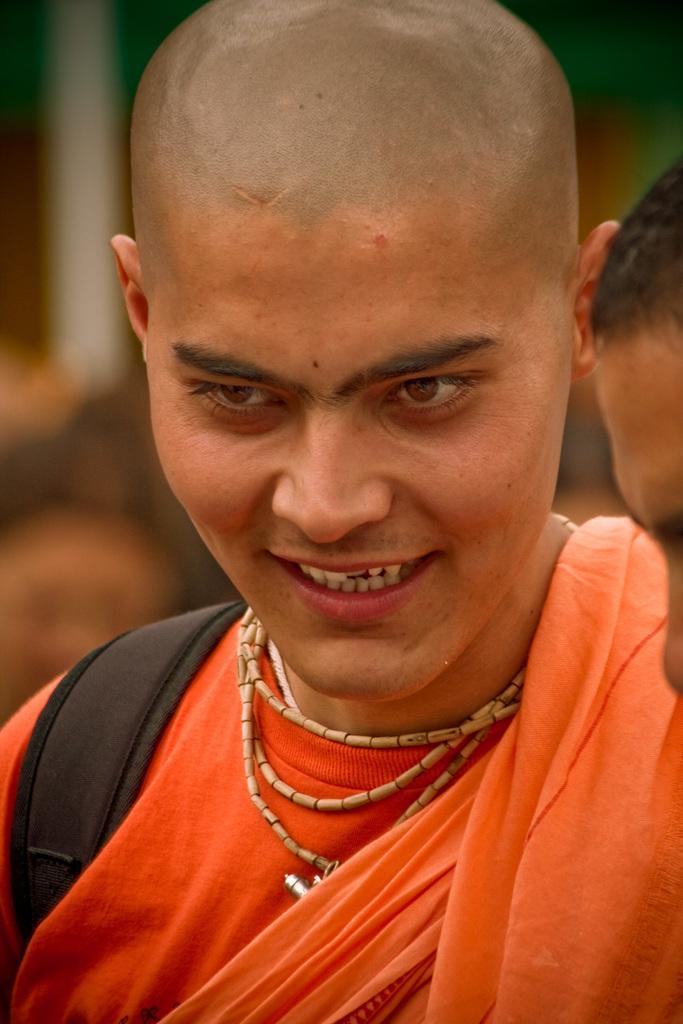Describe this image in one or two sentences. In this image I can see two people. One person is wearing an orange color dress. I think the person is wearing the black color bag. In the background I can see few more people but they are blurry. 